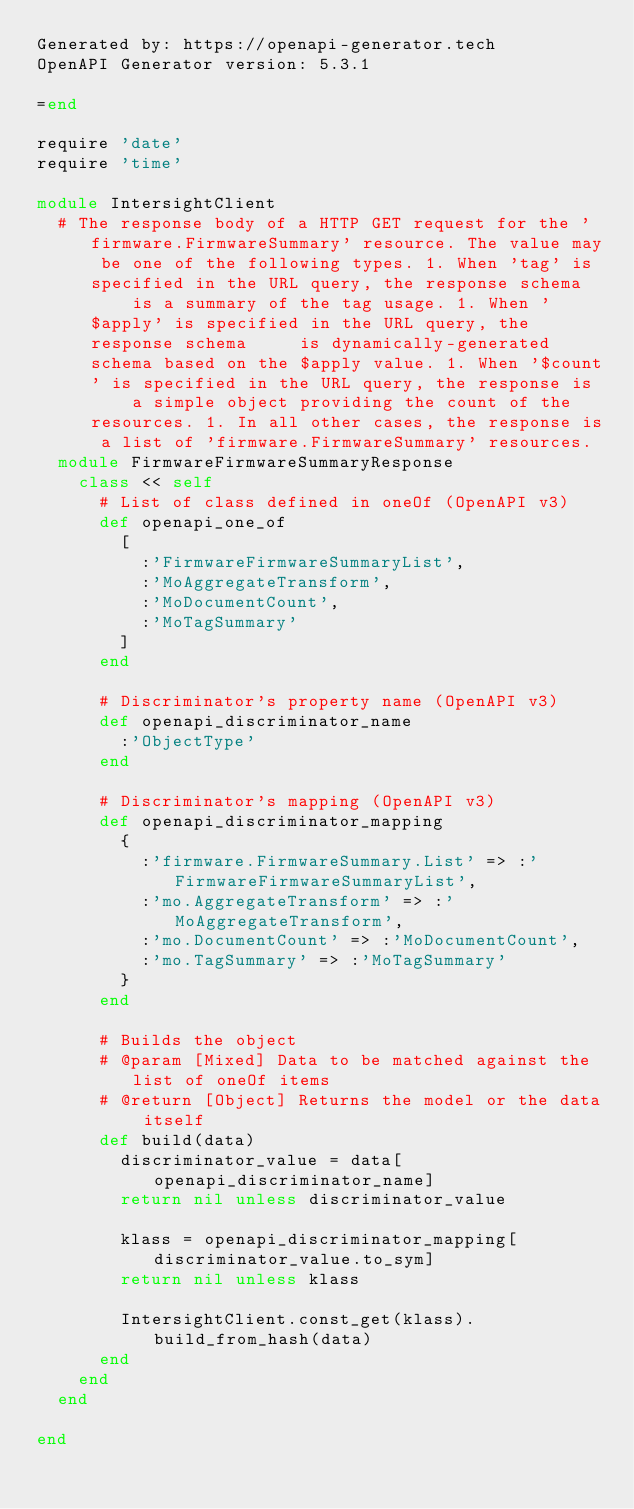Convert code to text. <code><loc_0><loc_0><loc_500><loc_500><_Ruby_>Generated by: https://openapi-generator.tech
OpenAPI Generator version: 5.3.1

=end

require 'date'
require 'time'

module IntersightClient
  # The response body of a HTTP GET request for the 'firmware.FirmwareSummary' resource. The value may be one of the following types. 1. When 'tag' is specified in the URL query, the response schema     is a summary of the tag usage. 1. When '$apply' is specified in the URL query, the response schema     is dynamically-generated schema based on the $apply value. 1. When '$count' is specified in the URL query, the response is     a simple object providing the count of the resources. 1. In all other cases, the response is a list of 'firmware.FirmwareSummary' resources.
  module FirmwareFirmwareSummaryResponse
    class << self
      # List of class defined in oneOf (OpenAPI v3)
      def openapi_one_of
        [
          :'FirmwareFirmwareSummaryList',
          :'MoAggregateTransform',
          :'MoDocumentCount',
          :'MoTagSummary'
        ]
      end

      # Discriminator's property name (OpenAPI v3)
      def openapi_discriminator_name
        :'ObjectType'
      end

      # Discriminator's mapping (OpenAPI v3)
      def openapi_discriminator_mapping
        {
          :'firmware.FirmwareSummary.List' => :'FirmwareFirmwareSummaryList',
          :'mo.AggregateTransform' => :'MoAggregateTransform',
          :'mo.DocumentCount' => :'MoDocumentCount',
          :'mo.TagSummary' => :'MoTagSummary'
        }
      end

      # Builds the object
      # @param [Mixed] Data to be matched against the list of oneOf items
      # @return [Object] Returns the model or the data itself
      def build(data)
        discriminator_value = data[openapi_discriminator_name]
        return nil unless discriminator_value

        klass = openapi_discriminator_mapping[discriminator_value.to_sym]
        return nil unless klass

        IntersightClient.const_get(klass).build_from_hash(data)
      end
    end
  end

end
</code> 